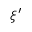Convert formula to latex. <formula><loc_0><loc_0><loc_500><loc_500>\xi ^ { \prime }</formula> 